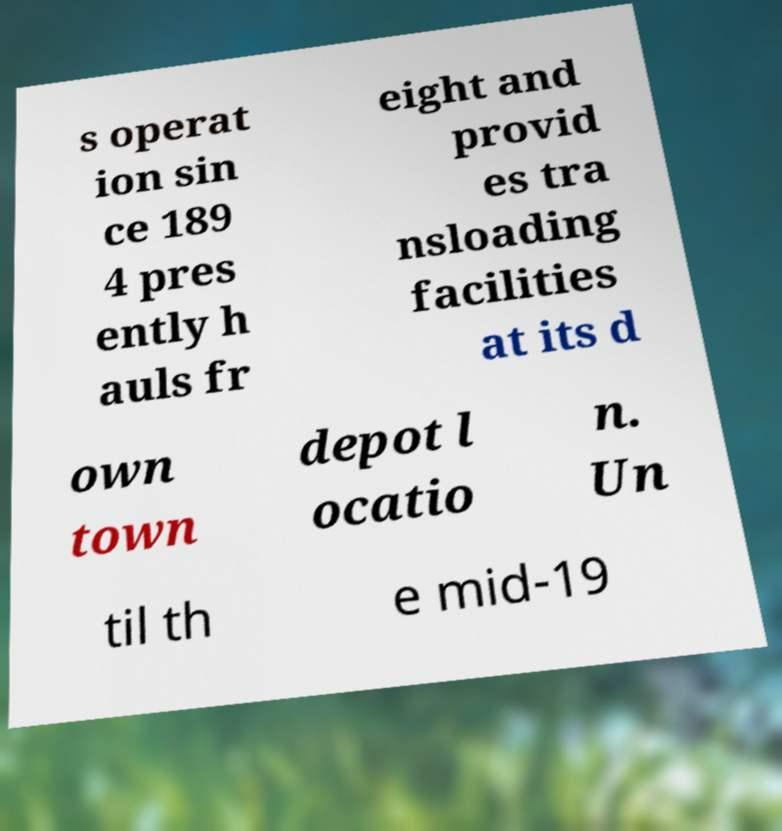Could you assist in decoding the text presented in this image and type it out clearly? s operat ion sin ce 189 4 pres ently h auls fr eight and provid es tra nsloading facilities at its d own town depot l ocatio n. Un til th e mid-19 